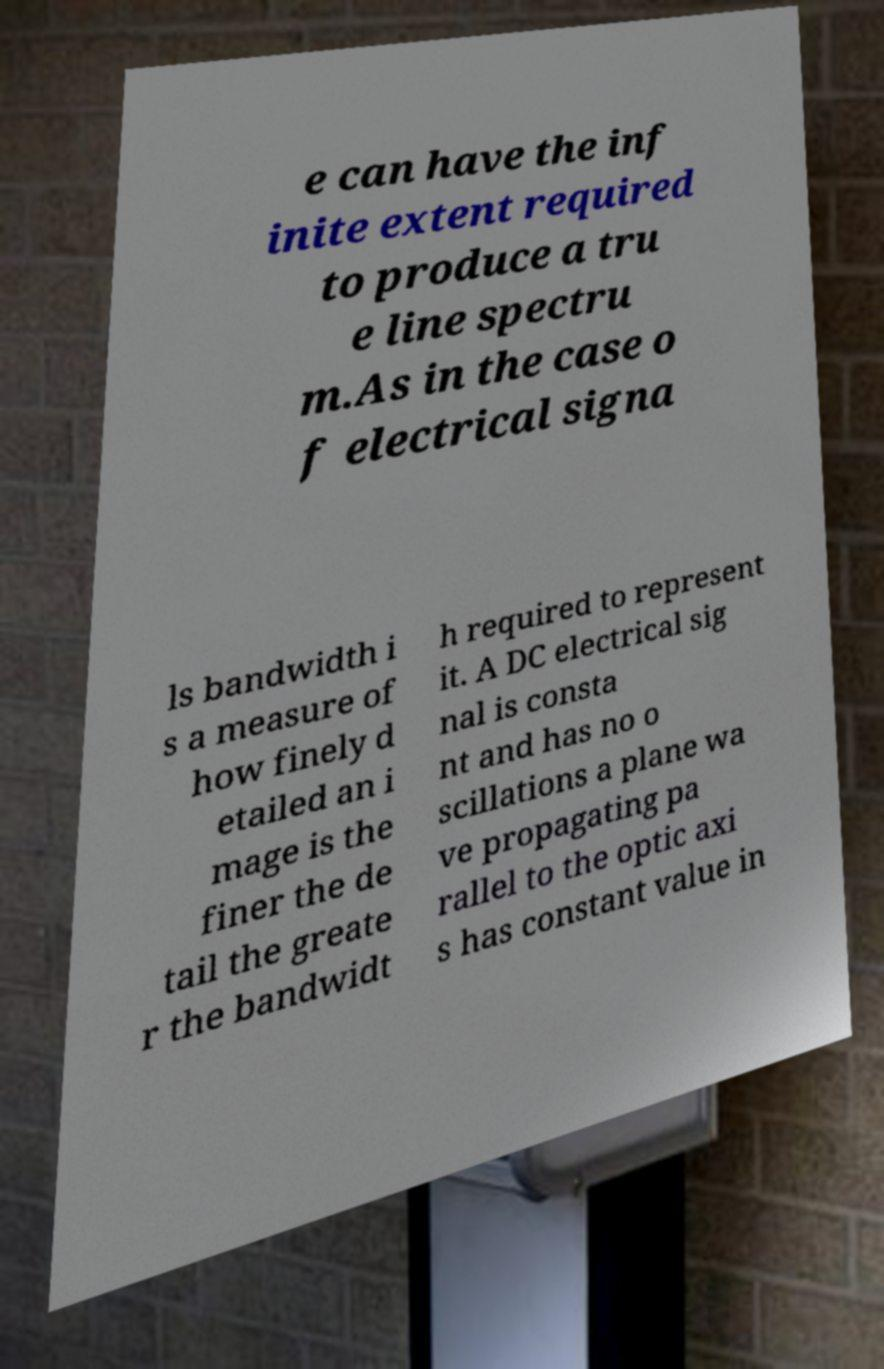For documentation purposes, I need the text within this image transcribed. Could you provide that? e can have the inf inite extent required to produce a tru e line spectru m.As in the case o f electrical signa ls bandwidth i s a measure of how finely d etailed an i mage is the finer the de tail the greate r the bandwidt h required to represent it. A DC electrical sig nal is consta nt and has no o scillations a plane wa ve propagating pa rallel to the optic axi s has constant value in 